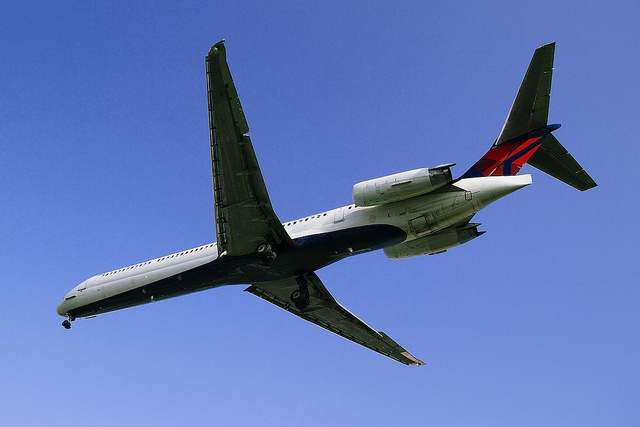Describe the objects in this image and their specific colors. I can see a airplane in blue, black, gray, lightgray, and darkgray tones in this image. 